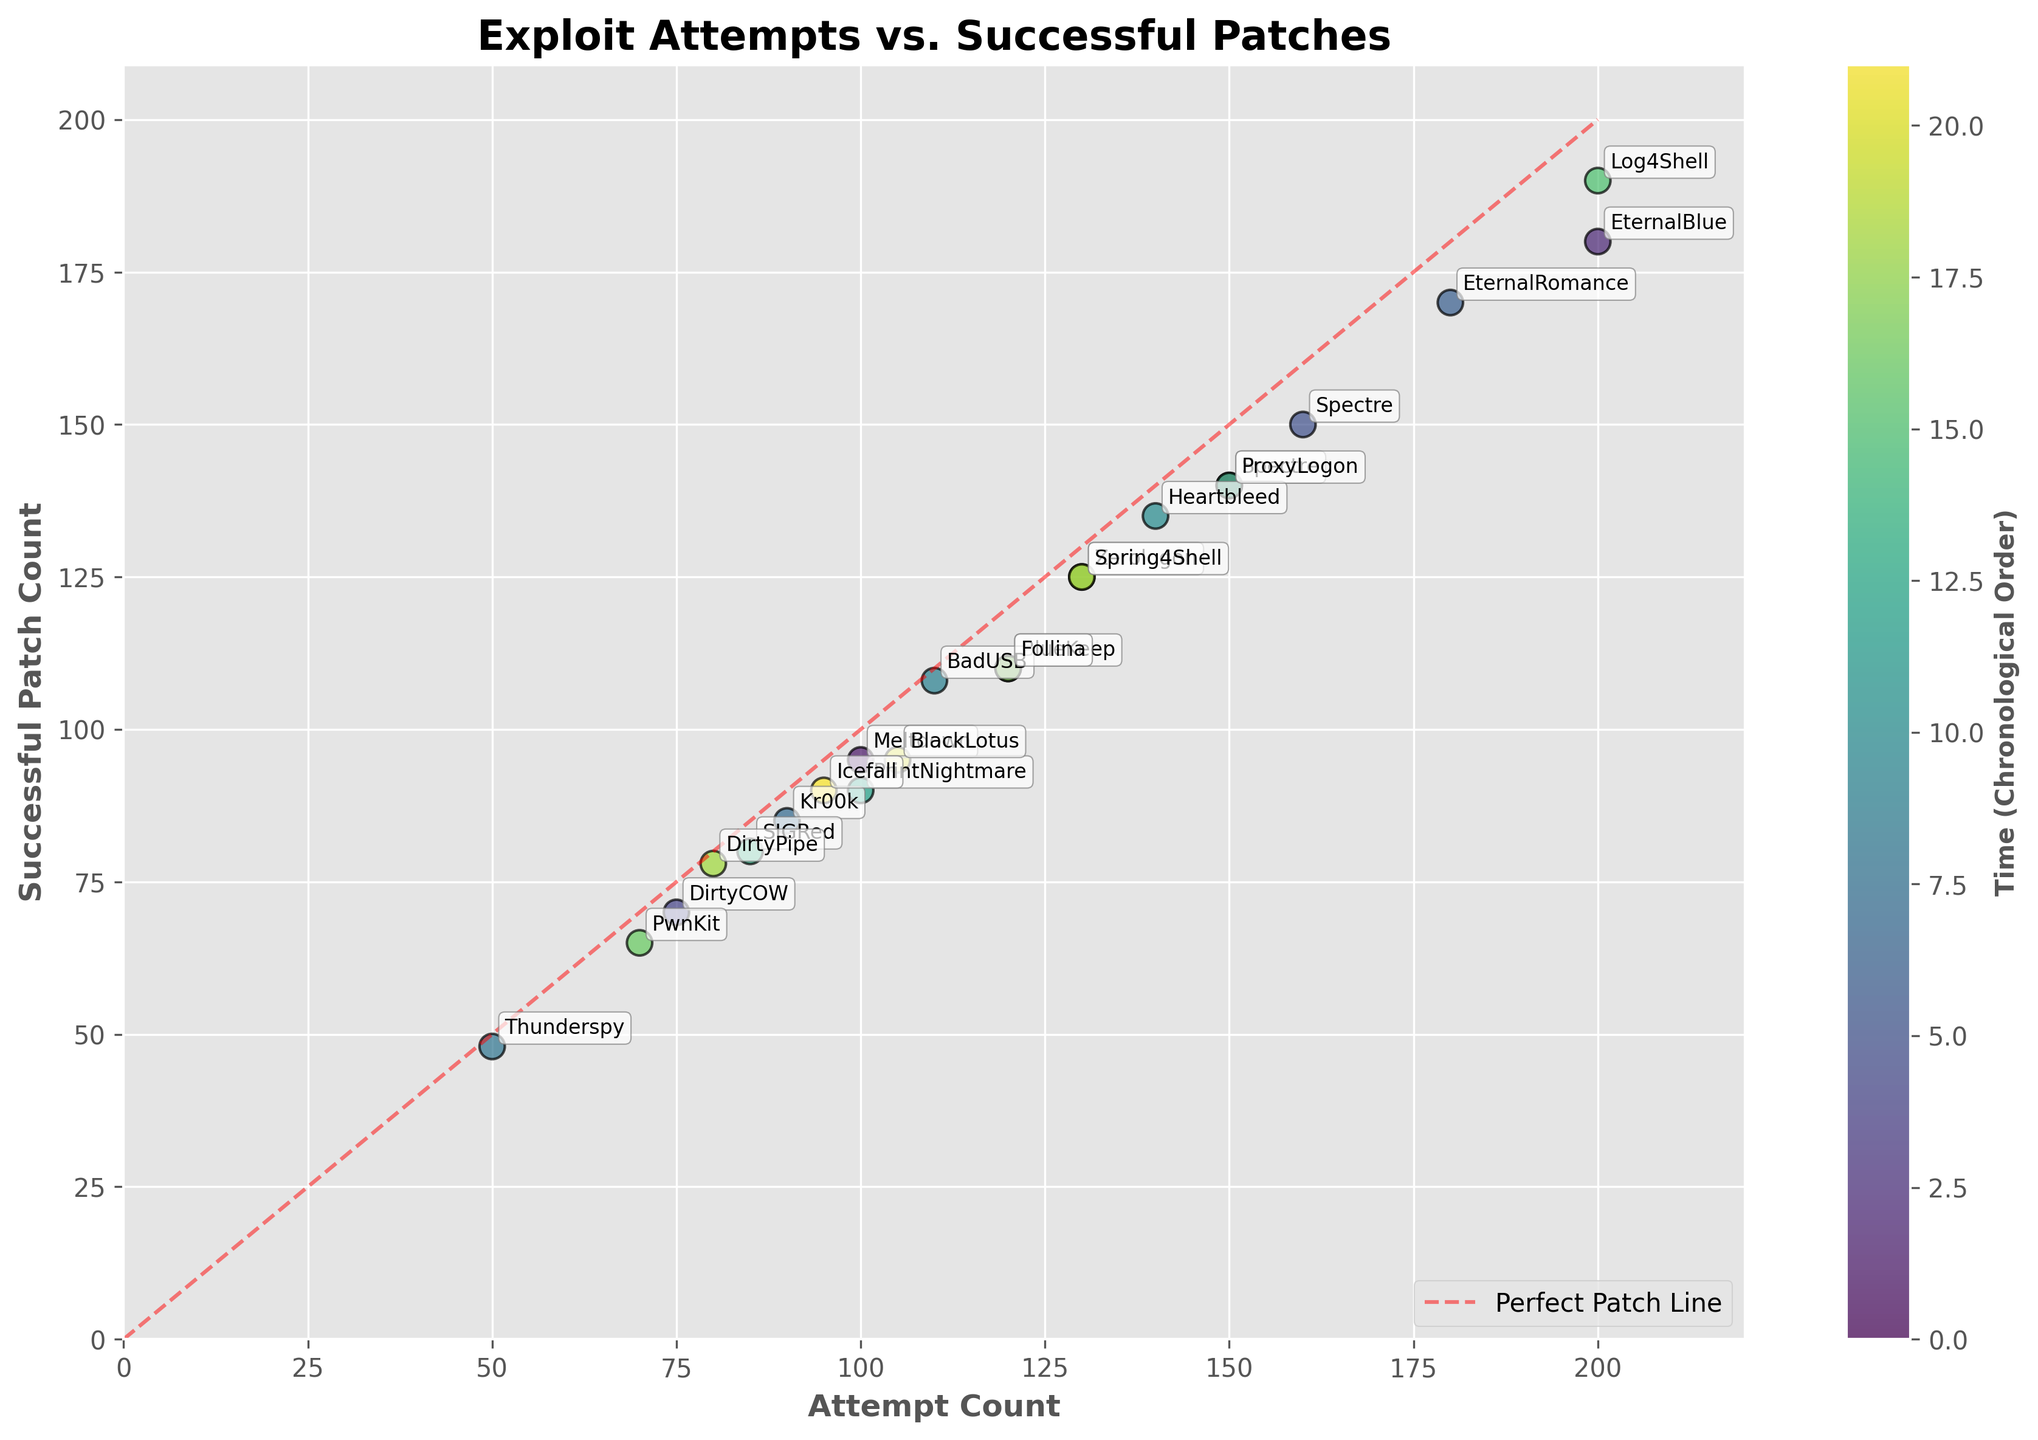Which exploit had the highest number of attempts? By reviewing the scatter plot, locate the data point that is farthest along the x-axis (Attempt Count). Check the annotation near this point for the exploit name.
Answer: EternalBlue Is there any exploit that had an attempt count exactly equal to its successful patch count? Observe the scatter plot for any data points lying directly on the red dashed "Perfect Patch Line." Check the annotations near these points.
Answer: No Which two exploits had the closest number of successful patches? Look for data points that are very close to each other along the y-axis (Successful Patch Count). Identify the exploits through their annotations and verify their patch counts.
Answer: Thunderspy and BadUSB How many exploits had more than 140 successful patches? Count the number of data points above the 140 value on the y-axis (Successful Patch Count).
Answer: Four Between 'Spectre' and 'Meltdown', which one had more successful patches in 2018? Locate the data points for 'Spectre' and 'Meltdown' specifically within 2018 (Q1 or Q2). Compare their y-axis values (Successful Patch Count).
Answer: Spectre What is the range of attempt counts observed in the plot? Identify the minimum and maximum values on the x-axis (Attempt Count) by examining the scatter plot. Calculate the difference between these two values.
Answer: 150 Which exploits had more than 100 attempts but fewer than 150 successful patches? Check the data points between 100 and 150 on the y-axis (Successful Patch Count) and simultaneously check their x-axis values (Attempt Count) to ensure they are above 100. Identify the exploits through their annotations.
Answer: Heartbleed, Zerologon, ProxyLogon Was 'Log4Shell' more successful in terms of patches compared to 'BlueKeep'? Locate the scatter plot points for 'Log4Shell' and 'BlueKeep.' Compare their y-axis values (Successful Patch Count).
Answer: Yes How many exploits are annotated within the figure? Count the number of unique exploit names annotated on the scatter plot.
Answer: 21 How does the number of attempts for 'Log4Shell' compare to 'BlueKeep'? Find the data points for 'Log4Shell' and 'BlueKeep' on the scatter plot. Compare their x-axis values (Attempt Count).
Answer: Greater 